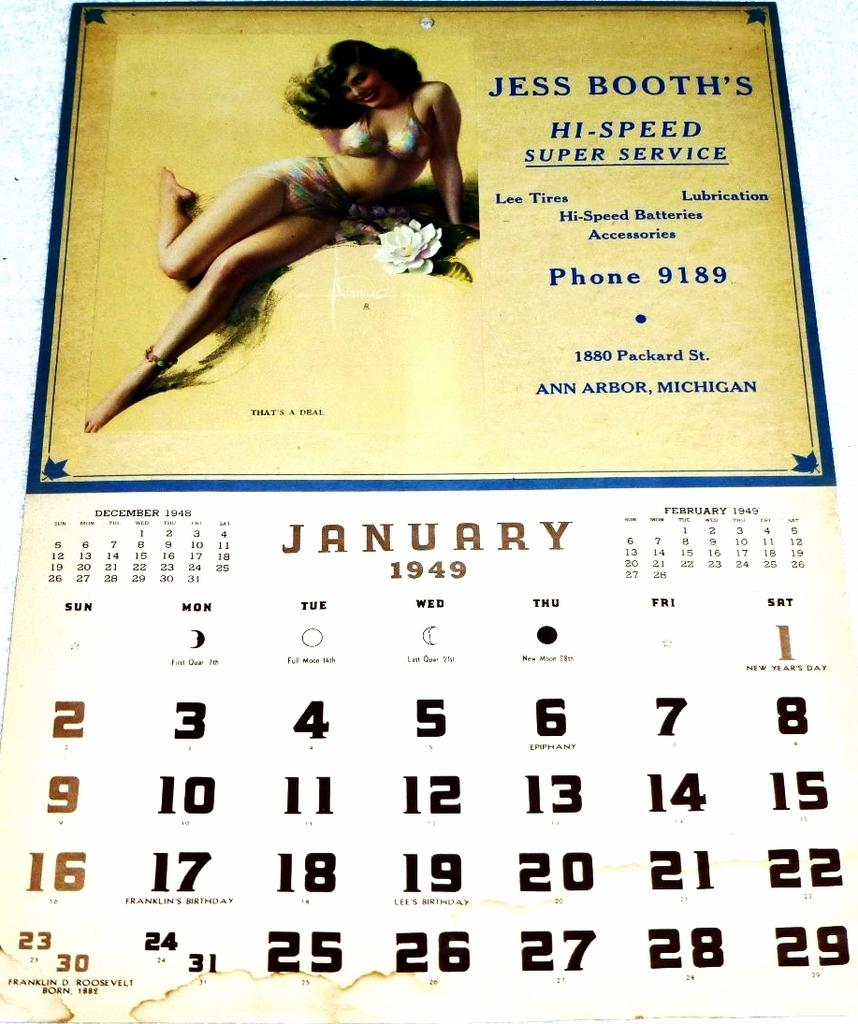What can be seen hanging on the wall in the image? There is a calendar in the image. Who is present in the image? There is a woman in the image. Can you read any text in the image? Yes, there is writing on the calendar or another object in the image. How many chickens are visible in the image? There are no chickens present in the image. What is the woman doing with her elbow in the image? The image does not show the woman using her elbow in any way. 